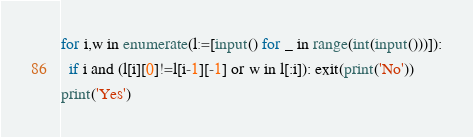Convert code to text. <code><loc_0><loc_0><loc_500><loc_500><_Python_>for i,w in enumerate(l:=[input() for _ in range(int(input()))]):
  if i and (l[i][0]!=l[i-1][-1] or w in l[:i]): exit(print('No'))
print('Yes')</code> 